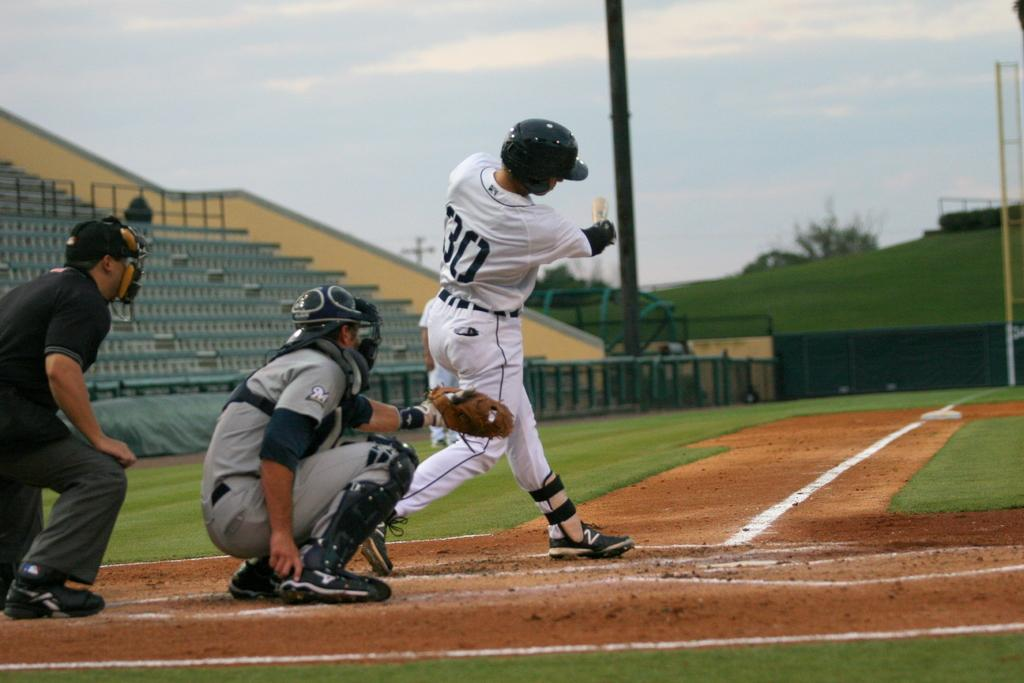<image>
Provide a brief description of the given image. The batter in the number 30 uniform has just taken a swing at the ball. 